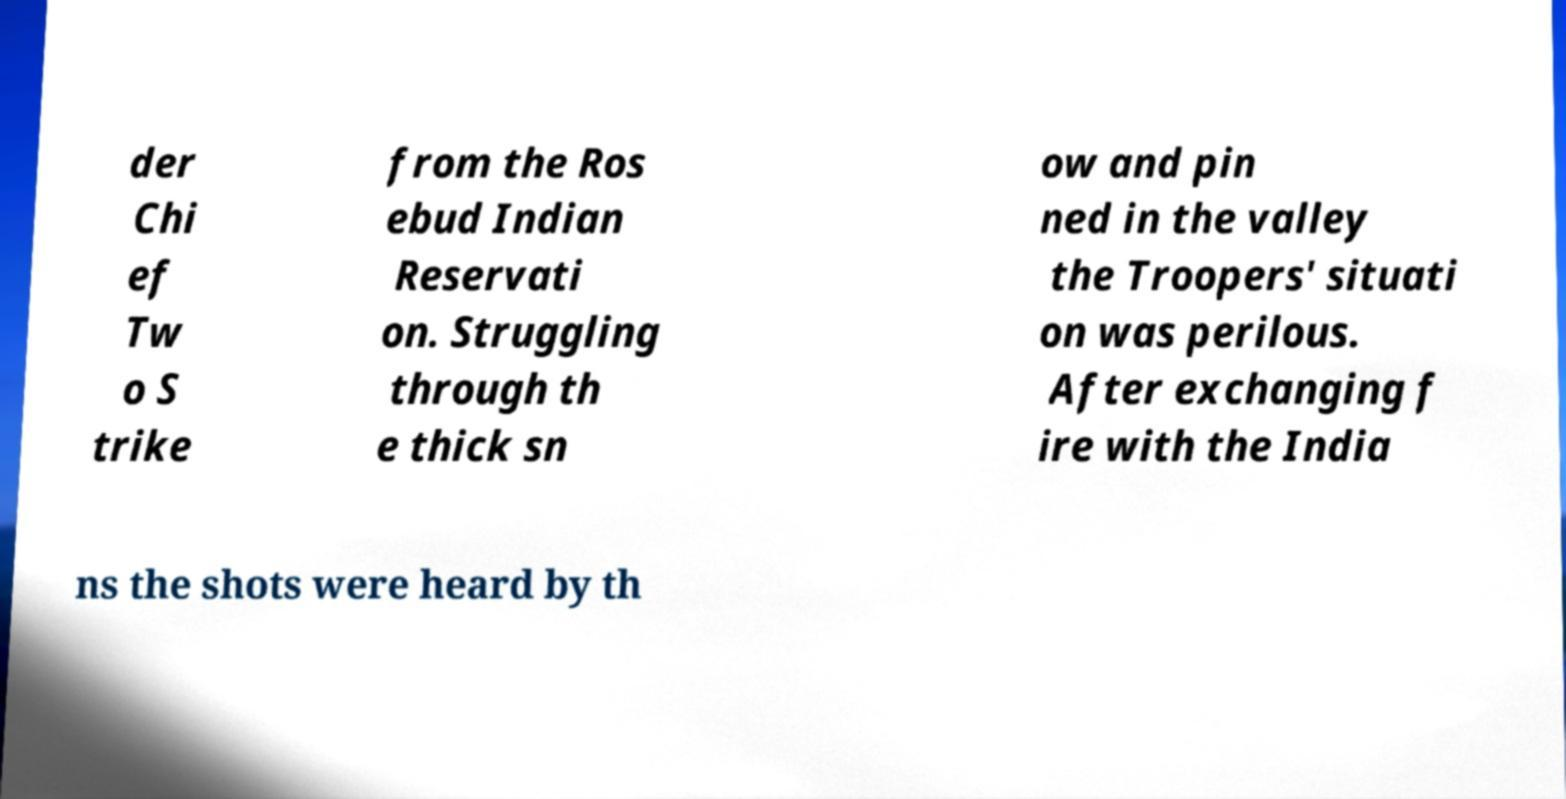Could you assist in decoding the text presented in this image and type it out clearly? der Chi ef Tw o S trike from the Ros ebud Indian Reservati on. Struggling through th e thick sn ow and pin ned in the valley the Troopers' situati on was perilous. After exchanging f ire with the India ns the shots were heard by th 